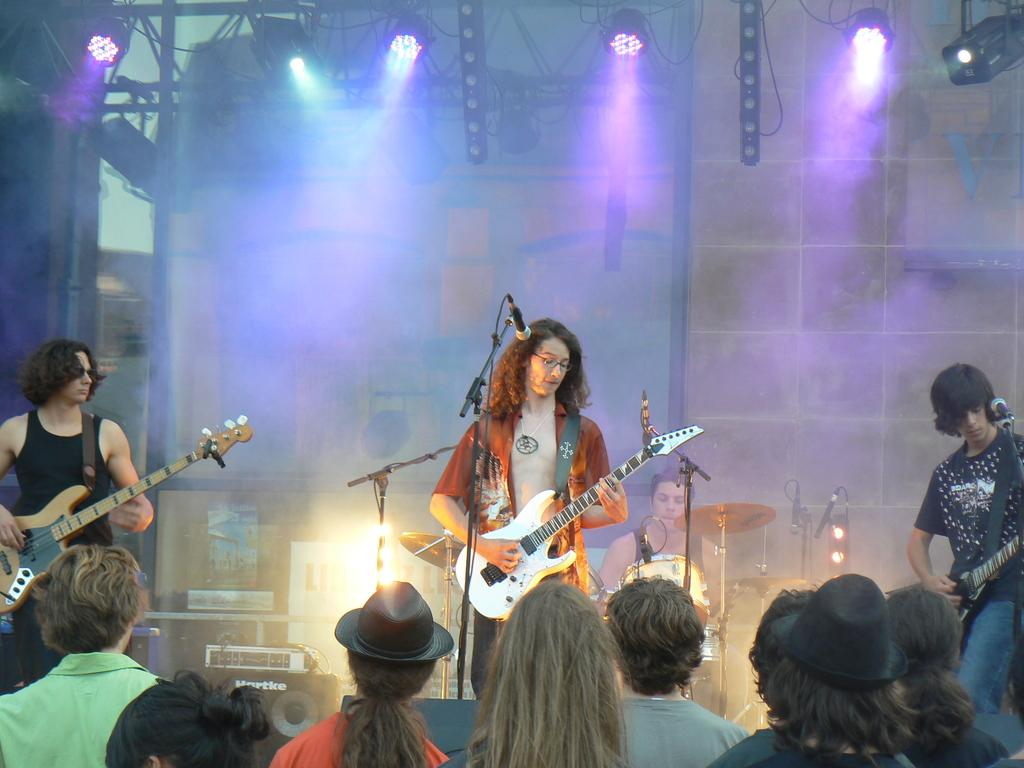How many men are in the image? There are three men in the image. What are the men holding in the image? Each of the men is holding a guitar. Can you describe the people present in the image? There are people present in the image. A: There are people present in the image, including the three men holding guitars. What can be seen in the background of the image? There are lights visible in the background. Is there anyone else in the background besides the lights? Yes, there is a man in the background. What is the man in the background doing? The man in the background is near drums. What is the size of the leaf in the image? There is no leaf present in the image. What substance is the guitar made of in the image? The provided facts do not mention the substance the guitars are made of, so we cannot determine that information from the image. 